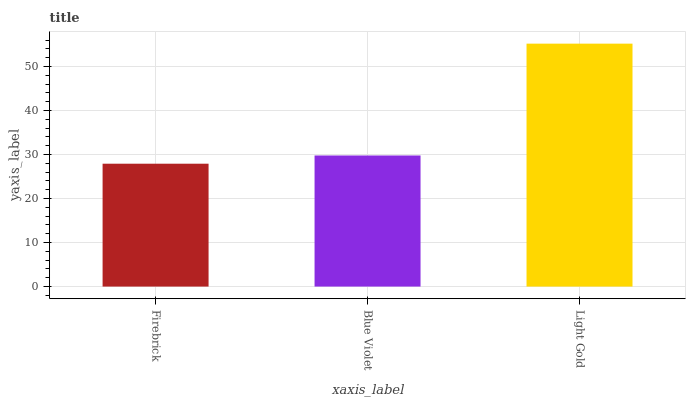Is Firebrick the minimum?
Answer yes or no. Yes. Is Light Gold the maximum?
Answer yes or no. Yes. Is Blue Violet the minimum?
Answer yes or no. No. Is Blue Violet the maximum?
Answer yes or no. No. Is Blue Violet greater than Firebrick?
Answer yes or no. Yes. Is Firebrick less than Blue Violet?
Answer yes or no. Yes. Is Firebrick greater than Blue Violet?
Answer yes or no. No. Is Blue Violet less than Firebrick?
Answer yes or no. No. Is Blue Violet the high median?
Answer yes or no. Yes. Is Blue Violet the low median?
Answer yes or no. Yes. Is Firebrick the high median?
Answer yes or no. No. Is Light Gold the low median?
Answer yes or no. No. 